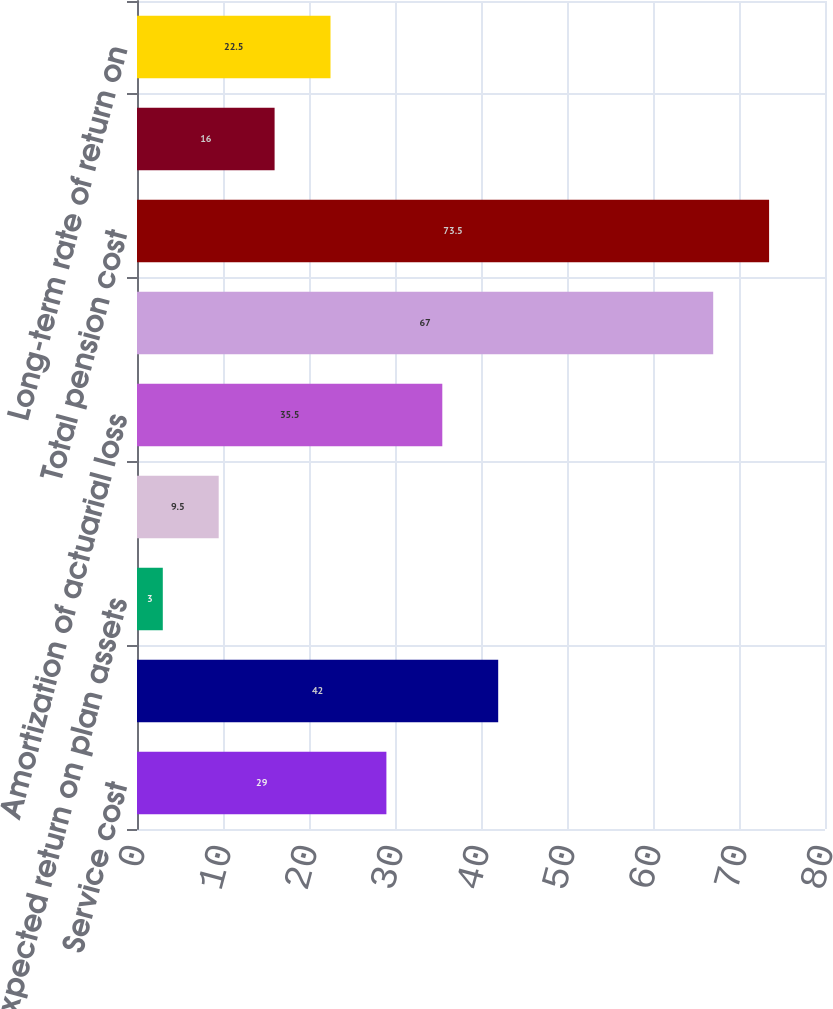<chart> <loc_0><loc_0><loc_500><loc_500><bar_chart><fcel>Service cost<fcel>Interest cost<fcel>Expected return on plan assets<fcel>Amortization of transition &<fcel>Amortization of actuarial loss<fcel>Net periodic benefit cost<fcel>Total pension cost<fcel>Discount rate<fcel>Long-term rate of return on<nl><fcel>29<fcel>42<fcel>3<fcel>9.5<fcel>35.5<fcel>67<fcel>73.5<fcel>16<fcel>22.5<nl></chart> 